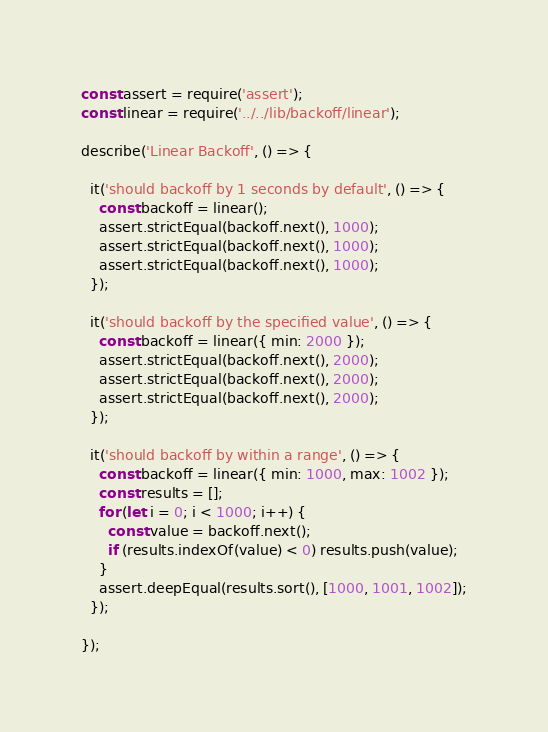<code> <loc_0><loc_0><loc_500><loc_500><_JavaScript_>const assert = require('assert');
const linear = require('../../lib/backoff/linear');

describe('Linear Backoff', () => {

  it('should backoff by 1 seconds by default', () => {
    const backoff = linear();
    assert.strictEqual(backoff.next(), 1000);
    assert.strictEqual(backoff.next(), 1000);
    assert.strictEqual(backoff.next(), 1000);
  });

  it('should backoff by the specified value', () => {
    const backoff = linear({ min: 2000 });
    assert.strictEqual(backoff.next(), 2000);
    assert.strictEqual(backoff.next(), 2000);
    assert.strictEqual(backoff.next(), 2000);
  });

  it('should backoff by within a range', () => {
    const backoff = linear({ min: 1000, max: 1002 });
    const results = [];
    for (let i = 0; i < 1000; i++) {
      const value = backoff.next();
      if (results.indexOf(value) < 0) results.push(value);
    }
    assert.deepEqual(results.sort(), [1000, 1001, 1002]);
  });

});
</code> 